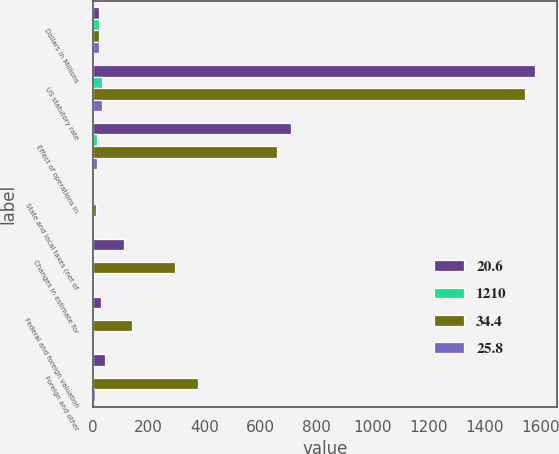<chart> <loc_0><loc_0><loc_500><loc_500><stacked_bar_chart><ecel><fcel>Dollars in Millions<fcel>US statutory rate<fcel>Effect of operations in<fcel>State and local taxes (net of<fcel>Changes in estimate for<fcel>Federal and foreign valuation<fcel>Foreign and other<nl><fcel>20.6<fcel>23.85<fcel>1581<fcel>708<fcel>2<fcel>114<fcel>32<fcel>46<nl><fcel>1210<fcel>23.85<fcel>35<fcel>15.7<fcel>0.1<fcel>2.5<fcel>0.7<fcel>1<nl><fcel>34.4<fcel>23.85<fcel>1546<fcel>660<fcel>14<fcel>293<fcel>142<fcel>375<nl><fcel>25.8<fcel>23.85<fcel>35<fcel>14.9<fcel>0.3<fcel>6.6<fcel>3.2<fcel>8.5<nl></chart> 